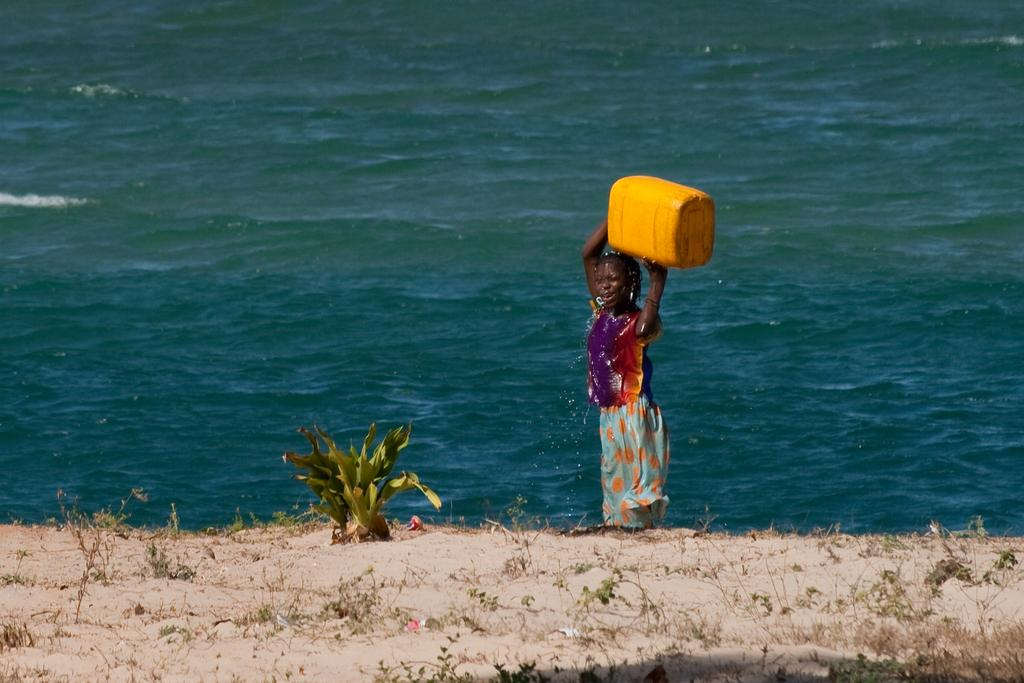What type of natural environment is depicted in the image? There is a sea in the image, which suggests a coastal or beach setting. What type of terrain is present in the image? There is sand in the image, which is commonly found at beaches. What type of vegetation can be seen in the image? There is a plant and creepers in the image, indicating the presence of some greenery. What is the person in the image doing? There is a person carrying a box in the image, suggesting they might be transporting or moving something. What type of airplane can be seen flying over the sea in the image? There is no airplane present in the image; it only features a sea, sand, plant, creepers, and a person carrying a box. 